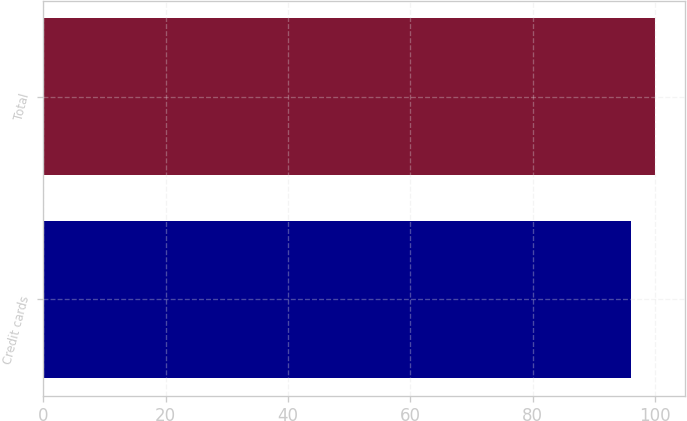<chart> <loc_0><loc_0><loc_500><loc_500><bar_chart><fcel>Credit cards<fcel>Total<nl><fcel>96.1<fcel>100<nl></chart> 